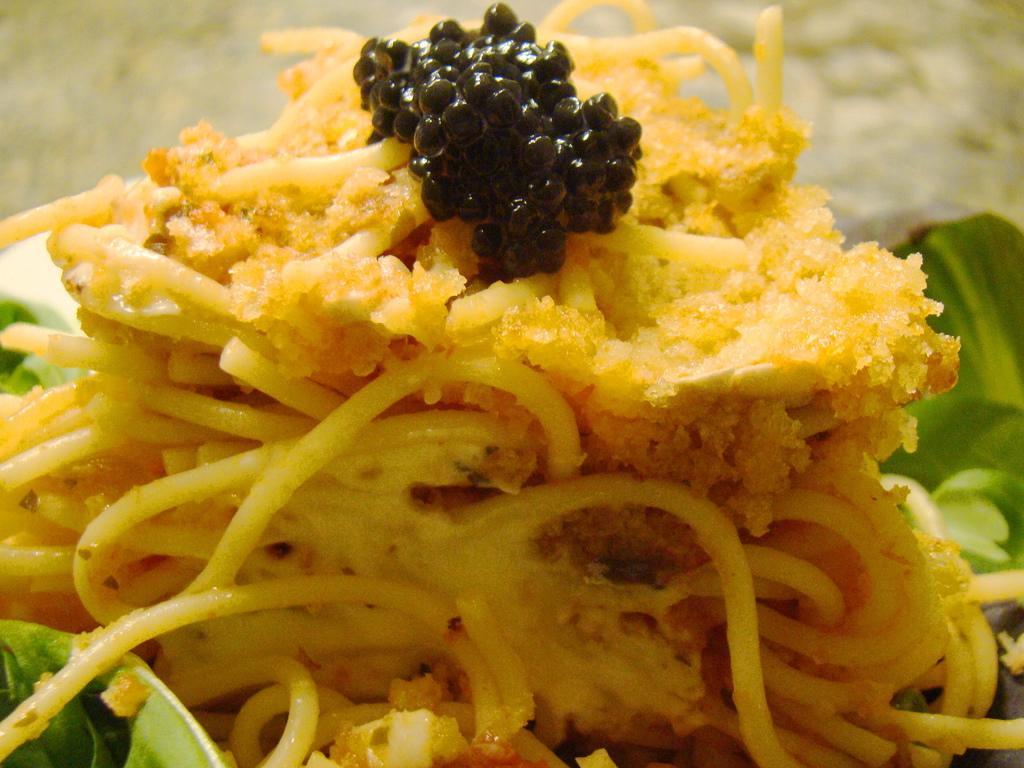In one or two sentences, can you explain what this image depicts? In the image there are noodles and some other food items. There is a black color food item and also there are green leaves. 